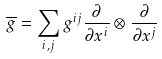<formula> <loc_0><loc_0><loc_500><loc_500>\overline { g } = \sum _ { i , j } g ^ { i j } \frac { \partial } { \partial x ^ { i } } \otimes \frac { \partial } { \partial x ^ { j } }</formula> 